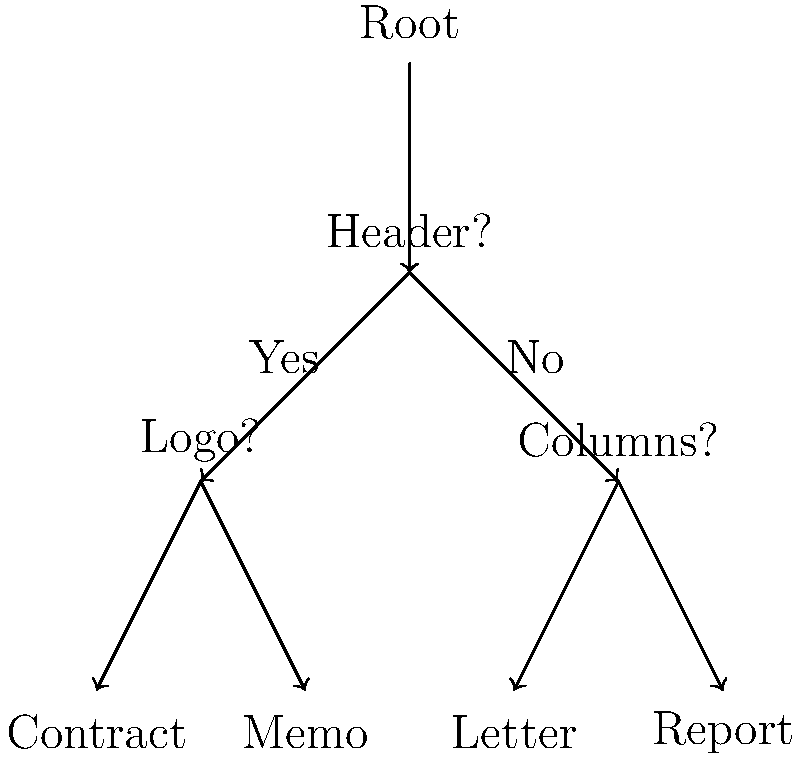As a judge who understands the importance of efficient document classification, how would you interpret this decision tree for classifying legal documents based on their visual layout? What type of document would be classified if it has a header but no logo? Let's interpret this decision tree step-by-step:

1. The root node represents the starting point of our classification process.

2. The first decision is based on whether the document has a header:
   - If yes, we move to the left branch.
   - If no, we move to the right branch.

3. In this case, we're told the document has a header, so we move left.

4. The next decision for documents with headers is whether they have a logo:
   - If yes, the document is classified as a Contract.
   - If no, the document is classified as a Memo.

5. Since our document has a header but no logo, we follow the "No" branch.

6. This leads us to the classification of "Memo".

This decision tree demonstrates how visual layout features can be used to quickly categorize legal documents, which is crucial for efficient document management in the legal system. As judges, we often deal with various types of legal documents, and such a classification system can greatly enhance our workflow.
Answer: Memo 